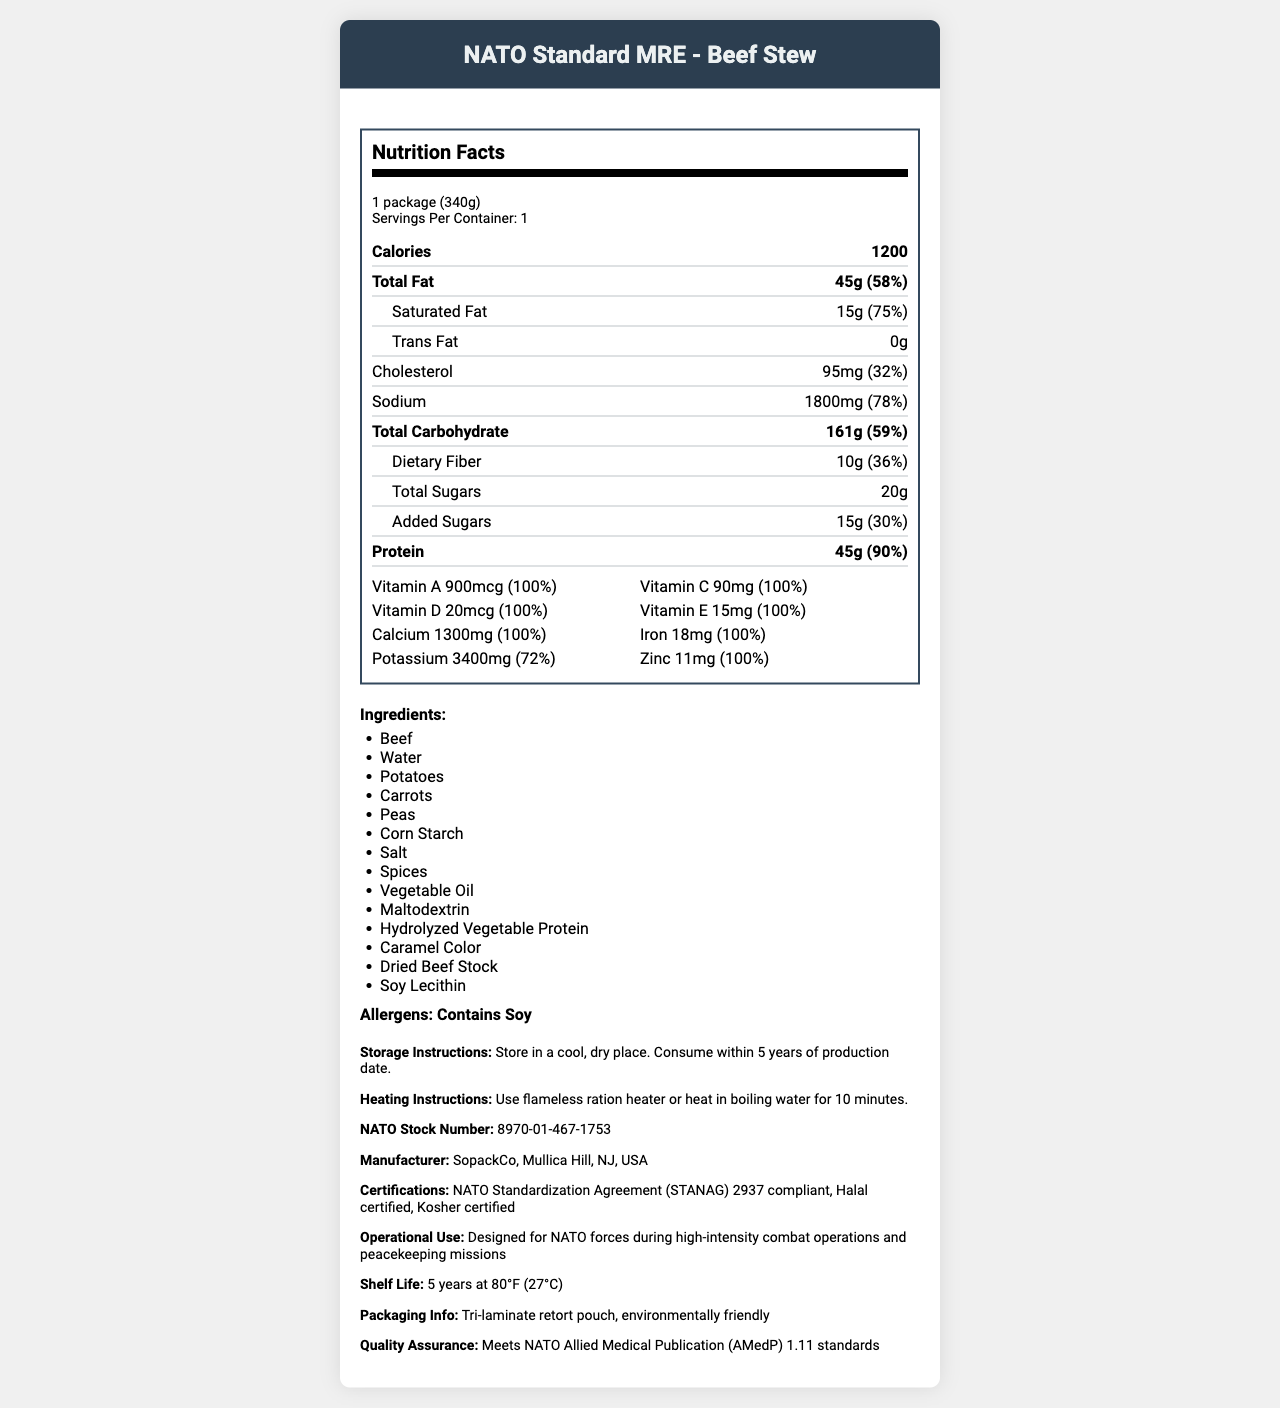what is the serving size of the product? The serving size is indicated at the top of the nutrition facts label: "1 package (340g)".
Answer: 1 package (340g) how many calories does one serving contain? The calories per serving are listed in the nutrition label under the "Calories" section.
Answer: 1200 what percentage of the daily value of saturated fat is in a serving? The saturated fat percentage of the daily value is listed adjacent to the amount of saturated fat: "15g (75%)".
Answer: 75% how much sodium does one serving contain? The amount of sodium is listed in the nutrition label: "Sodium 1800mg (78%)".
Answer: 1800mg how much protein is in a serving and what percentage of daily value does this represent? The protein content and its percent daily value are listed together: "Protein 45g (90%)".
Answer: 45g, 90% which of the following vitamins are 100% of the daily value in this MRE? A. Vitamin C B. Vitamin A C. Vitamin D D. All of the above The vitamins section lists Vitamin A, Vitamin C, and Vitamin D all at 100% of daily value.
Answer: D. All of the above how many milligrams of potassium are in the product?  A. 1500mg B. 2200mg C. 3400mg The amount of potassium is listed under minerals: "Potassium 3400mg (72%)".
Answer: C. 3400mg is there any trans fat in this product? The trans fat content is listed as "0g" on the nutrition label.
Answer: No is the product halal and kosher certified? The certifications section lists "Halal certified" and "Kosher certified".
Answer: Yes summarize the main idea of the document. The document comprehensively describes the nutritional content and other relevant details for a military ration used by NATO forces, indicating its suitability for high-intensity combat and peacekeeping missions. The product meets multiple certification standards and has a long shelf life.
Answer: The document provides detailed nutritional information about the "NATO Standard MRE - Beef Stew". It includes serving size, calories, fat, cholesterol, sodium, carbohydrates, protein, vitamins, and minerals with their respective quantities and daily values. It also lists ingredients, allergens, storage and heating instructions, MRE components, and additional information such as manufacturer, certifications, shelf life, and packaging. what is the primary operational use of this MRE? The operational use is explicitly stated in the additional information section.
Answer: Designed for NATO forces during high-intensity combat operations and peacekeeping missions what types of additional accessories are included with this MRE? The side dish components are detailed, including a variety of accessories for convenience.
Answer: Spoon, Napkin, Salt, Sugar, Coffee, Creamer, Matches, Toilet Paper what is the NATO stock number for this MRE? The NATO stock number is listed in the additional information section.
Answer: 8970-01-467-1753 identify the ingredient that is a potential allergen. The allergens section mentions "Contains Soy", an allergenic ingredient included in the ingredients list.
Answer: Soy how long is the shelf life of this MRE if stored correctly? The shelf life is explicitly mentioned in the additional information section.
Answer: 5 years at 80°F (27°C) what are the heating instructions for this MRE? The heating instructions are clearly provided in the document.
Answer: Use flameless ration heater or heat in boiling water for 10 minutes which company manufactures this MRE? The manufacturer information is detailed in the additional information section.
Answer: SopackCo, Mullica Hill, NJ, USA what percentage of daily value of dietary fiber is in this product? The percentage of daily value for dietary fiber is listed: "10g (36%)".
Answer: 36% how much calcium does the MRE contain? The amount of calcium is listed under minerals: "Calcium 1300mg (100%)".
Answer: 1300mg does the document mention any specific vitamins not included in the MRE? The document only lists the vitamins and minerals that are present but does not mention ones that are absent.
Answer: Not enough information what is the packaging type of the MRE? This information is provided in the packaging info section of the additional information.
Answer: Tri-laminate retort pouch, environmentally friendly 